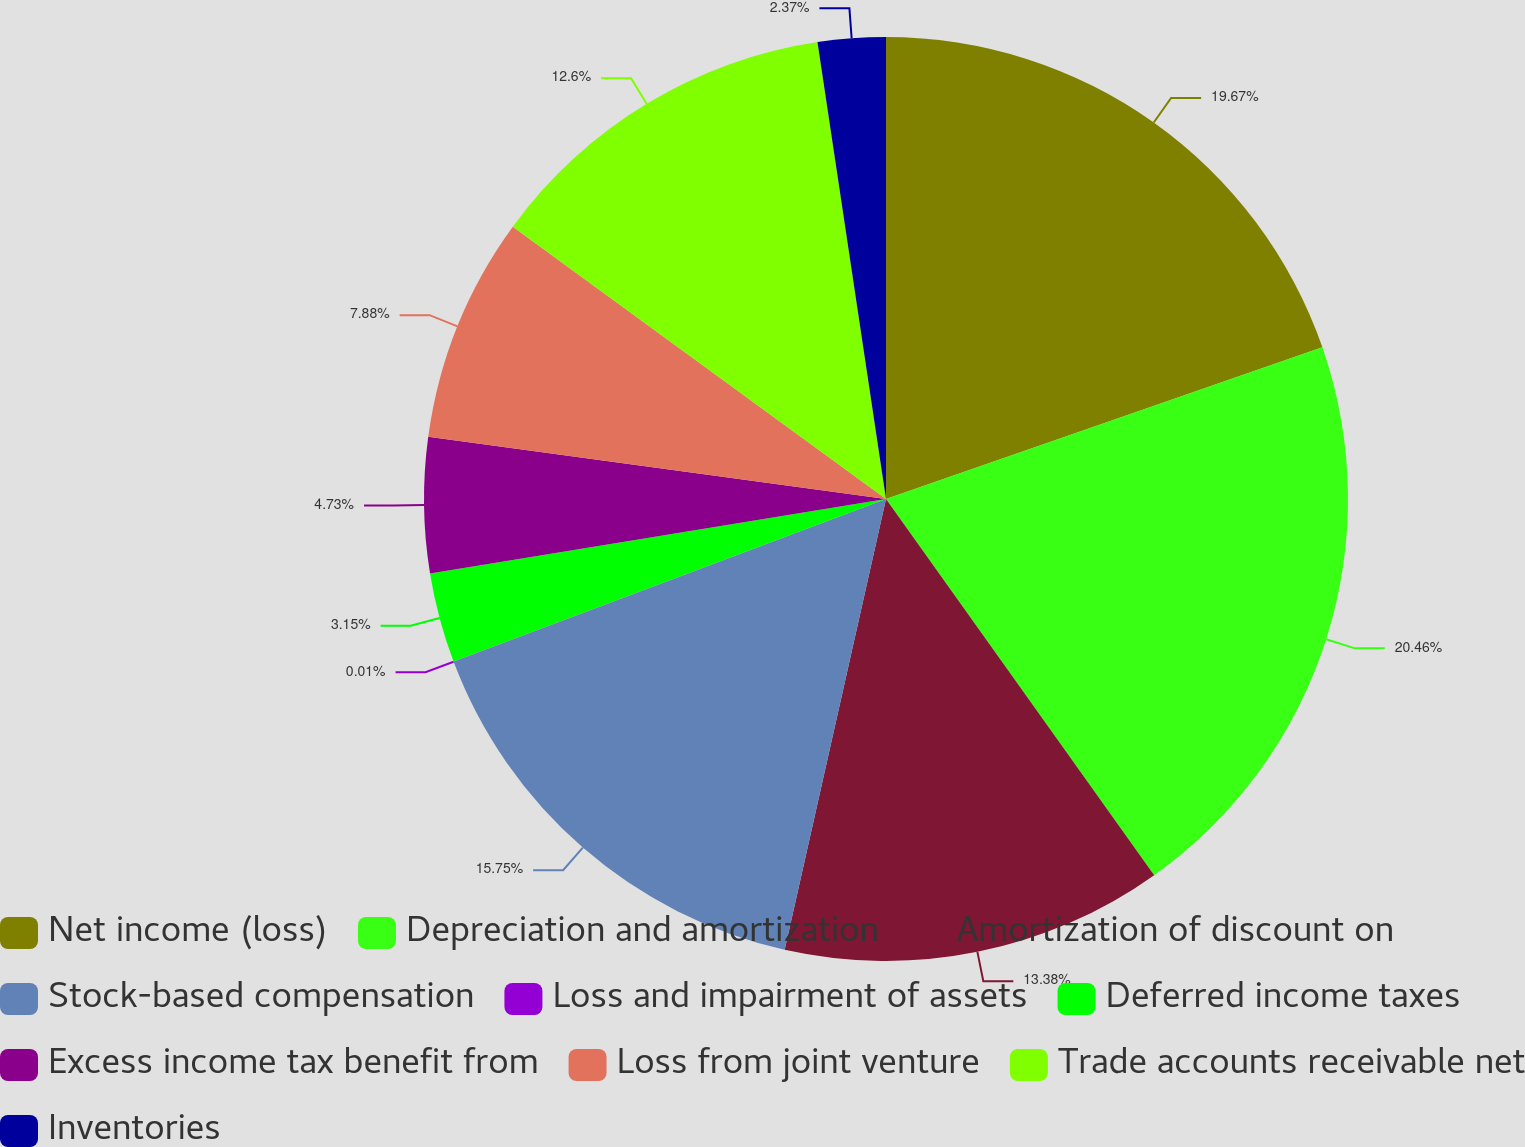<chart> <loc_0><loc_0><loc_500><loc_500><pie_chart><fcel>Net income (loss)<fcel>Depreciation and amortization<fcel>Amortization of discount on<fcel>Stock-based compensation<fcel>Loss and impairment of assets<fcel>Deferred income taxes<fcel>Excess income tax benefit from<fcel>Loss from joint venture<fcel>Trade accounts receivable net<fcel>Inventories<nl><fcel>19.68%<fcel>20.47%<fcel>13.38%<fcel>15.75%<fcel>0.01%<fcel>3.15%<fcel>4.73%<fcel>7.88%<fcel>12.6%<fcel>2.37%<nl></chart> 